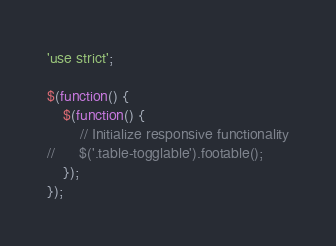<code> <loc_0><loc_0><loc_500><loc_500><_JavaScript_>'use strict';

$(function() {
	$(function() {
		// Initialize responsive functionality
//		$('.table-togglable').footable();	
	});
});</code> 